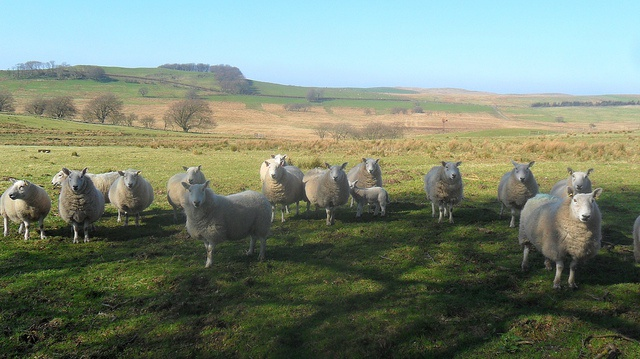Describe the objects in this image and their specific colors. I can see sheep in lightblue, gray, black, and darkgray tones, sheep in lightblue, gray, black, and darkgray tones, sheep in lightblue, darkgray, gray, tan, and black tones, sheep in lightblue, black, gray, darkgray, and tan tones, and sheep in lightblue, gray, black, tan, and darkgray tones in this image. 